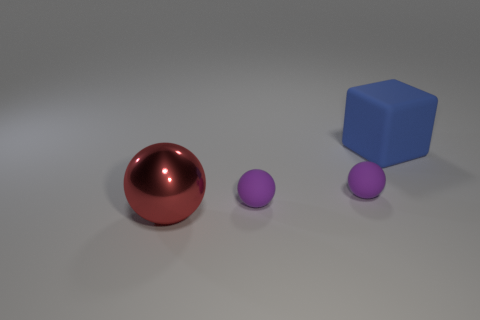What color is the large object that is behind the large metal object?
Provide a short and direct response. Blue. The metallic thing that is the same size as the blue rubber thing is what shape?
Your answer should be very brief. Sphere. Is the color of the metal object the same as the large thing to the right of the red thing?
Make the answer very short. No. How many things are either large things that are behind the big metal thing or large objects that are behind the big red sphere?
Your response must be concise. 1. There is a blue block that is the same size as the metal sphere; what material is it?
Give a very brief answer. Rubber. What number of other objects are there of the same material as the blue object?
Make the answer very short. 2. Does the large object that is in front of the blue matte object have the same shape as the large object that is right of the large shiny object?
Offer a terse response. No. There is a large thing that is on the left side of the big thing behind the large object that is to the left of the cube; what is its color?
Make the answer very short. Red. How many other things are there of the same color as the big cube?
Keep it short and to the point. 0. Is the number of tiny purple balls less than the number of small gray rubber things?
Provide a short and direct response. No. 